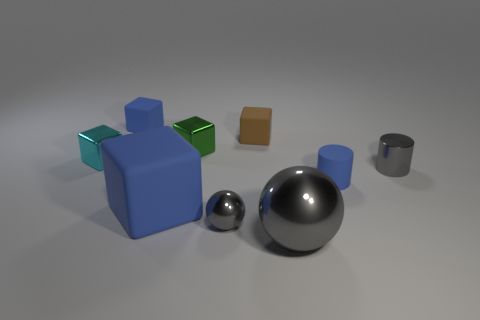Subtract all green metal blocks. How many blocks are left? 4 Subtract all green cubes. How many cubes are left? 4 Subtract all yellow blocks. Subtract all gray balls. How many blocks are left? 5 Add 1 big blue objects. How many objects exist? 10 Subtract all spheres. How many objects are left? 7 Subtract 1 cyan cubes. How many objects are left? 8 Subtract all blue objects. Subtract all big metallic balls. How many objects are left? 5 Add 5 small gray cylinders. How many small gray cylinders are left? 6 Add 8 large blue things. How many large blue things exist? 9 